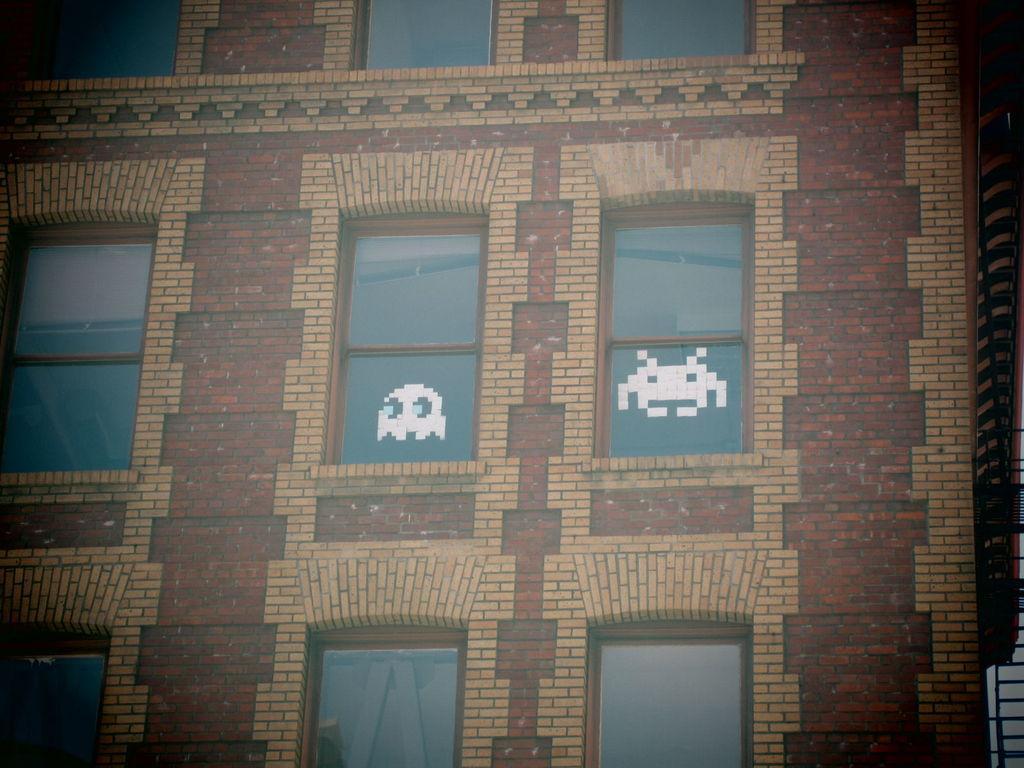Can you describe this image briefly? This is an animated picture. I can see a building with windows. 